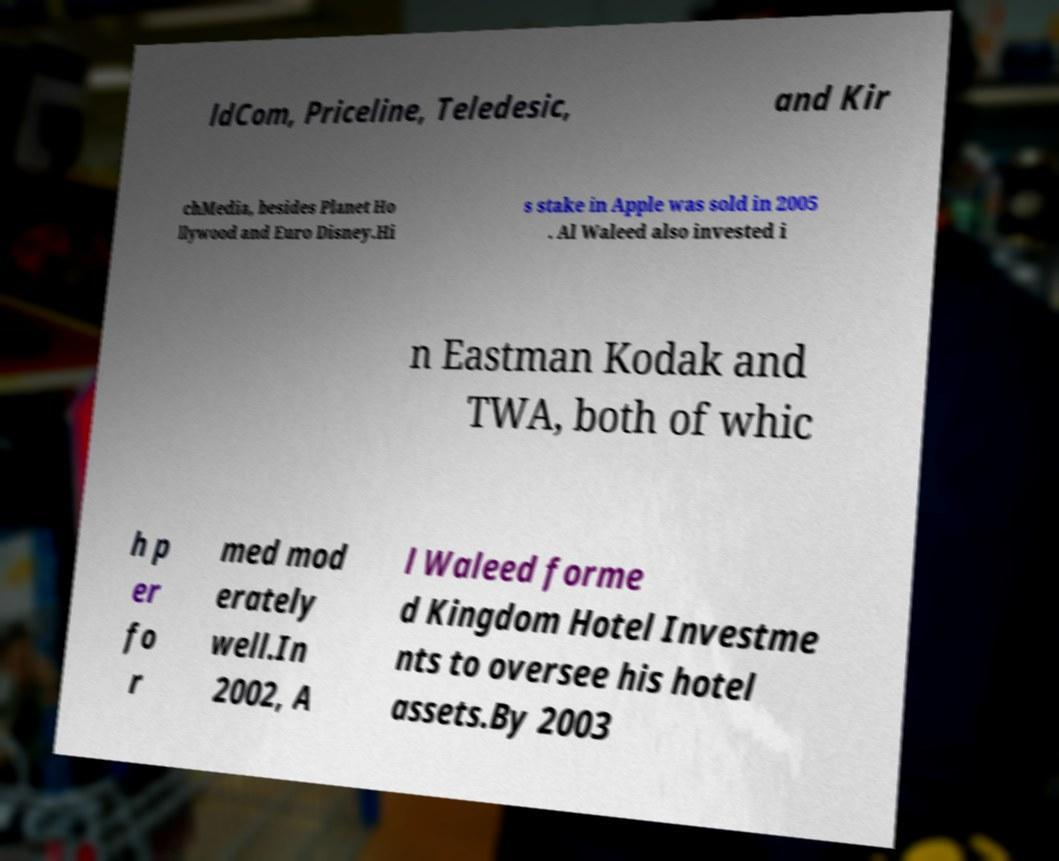Please identify and transcribe the text found in this image. ldCom, Priceline, Teledesic, and Kir chMedia, besides Planet Ho llywood and Euro Disney.Hi s stake in Apple was sold in 2005 . Al Waleed also invested i n Eastman Kodak and TWA, both of whic h p er fo r med mod erately well.In 2002, A l Waleed forme d Kingdom Hotel Investme nts to oversee his hotel assets.By 2003 